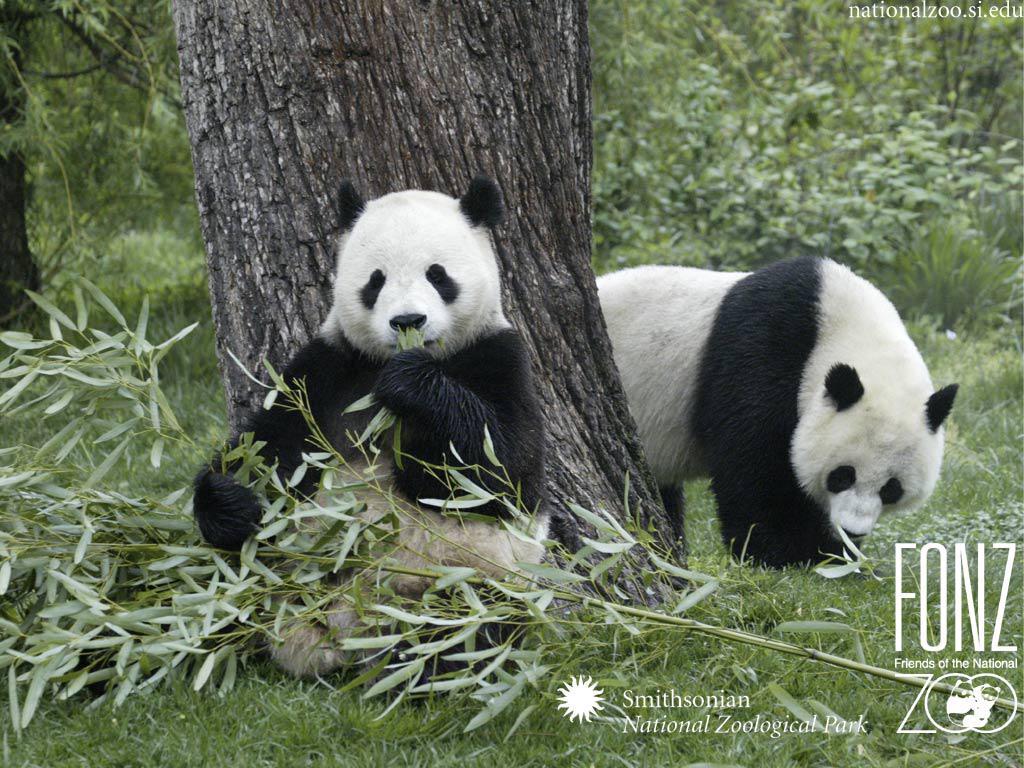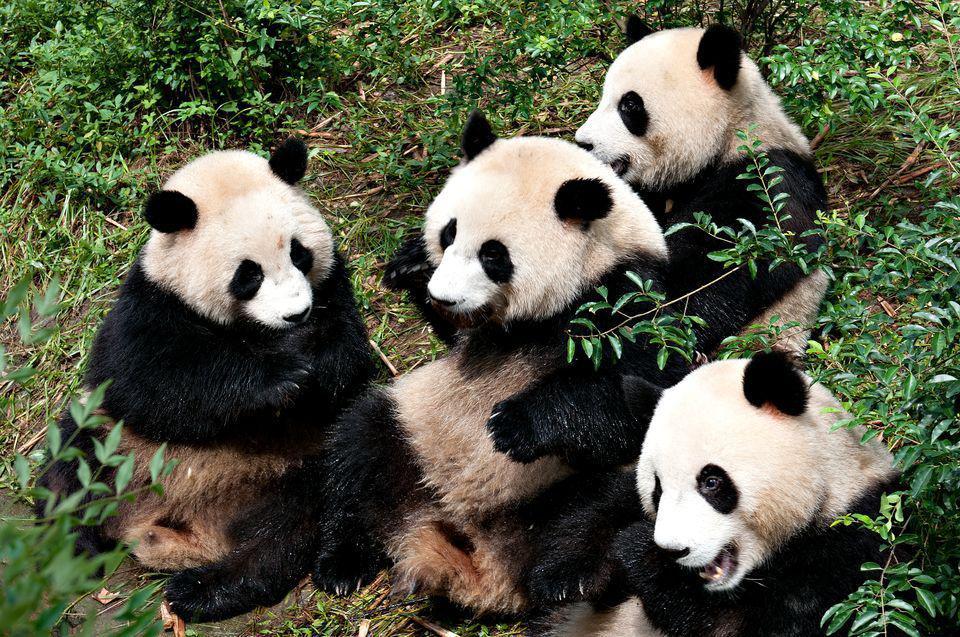The first image is the image on the left, the second image is the image on the right. Considering the images on both sides, is "An image shows two pandas who appear to be playfully wrestling." valid? Answer yes or no. No. The first image is the image on the left, the second image is the image on the right. Considering the images on both sides, is "there are  exactly four pandas in one of the images" valid? Answer yes or no. Yes. 